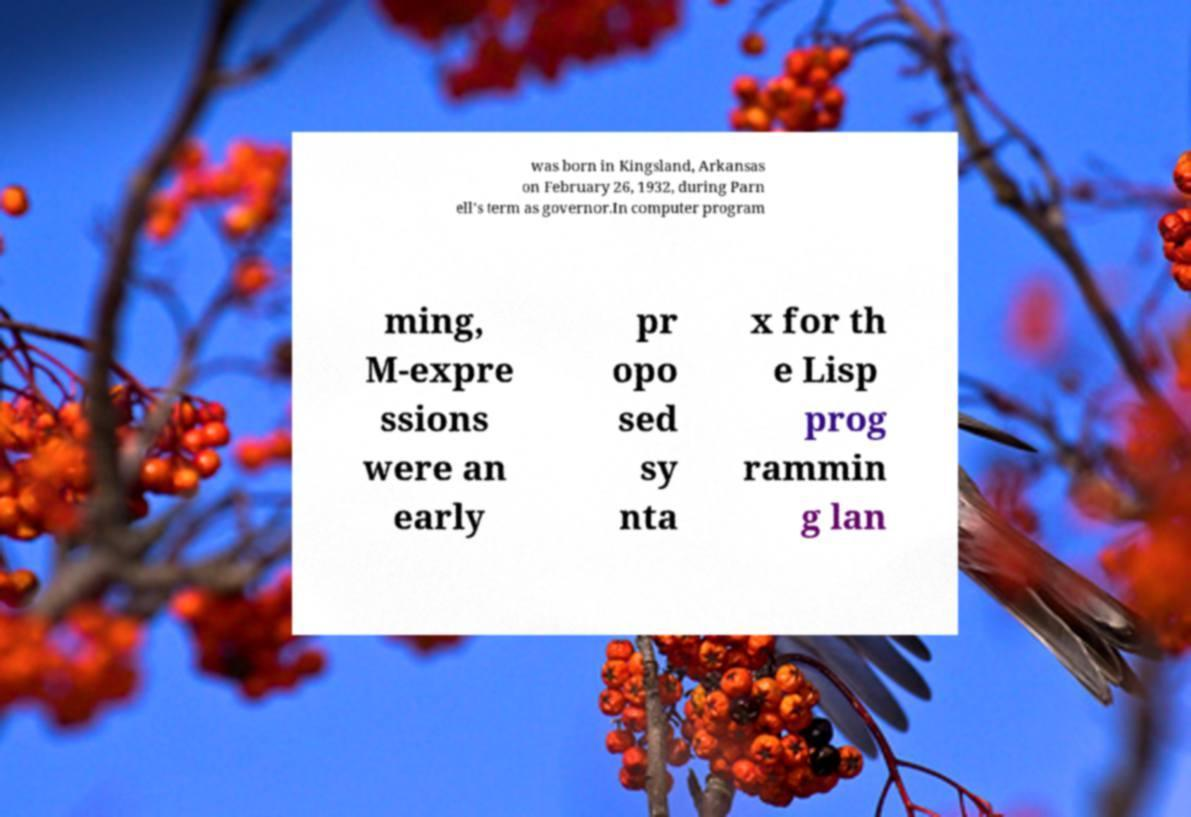Can you read and provide the text displayed in the image?This photo seems to have some interesting text. Can you extract and type it out for me? was born in Kingsland, Arkansas on February 26, 1932, during Parn ell's term as governor.In computer program ming, M-expre ssions were an early pr opo sed sy nta x for th e Lisp prog rammin g lan 